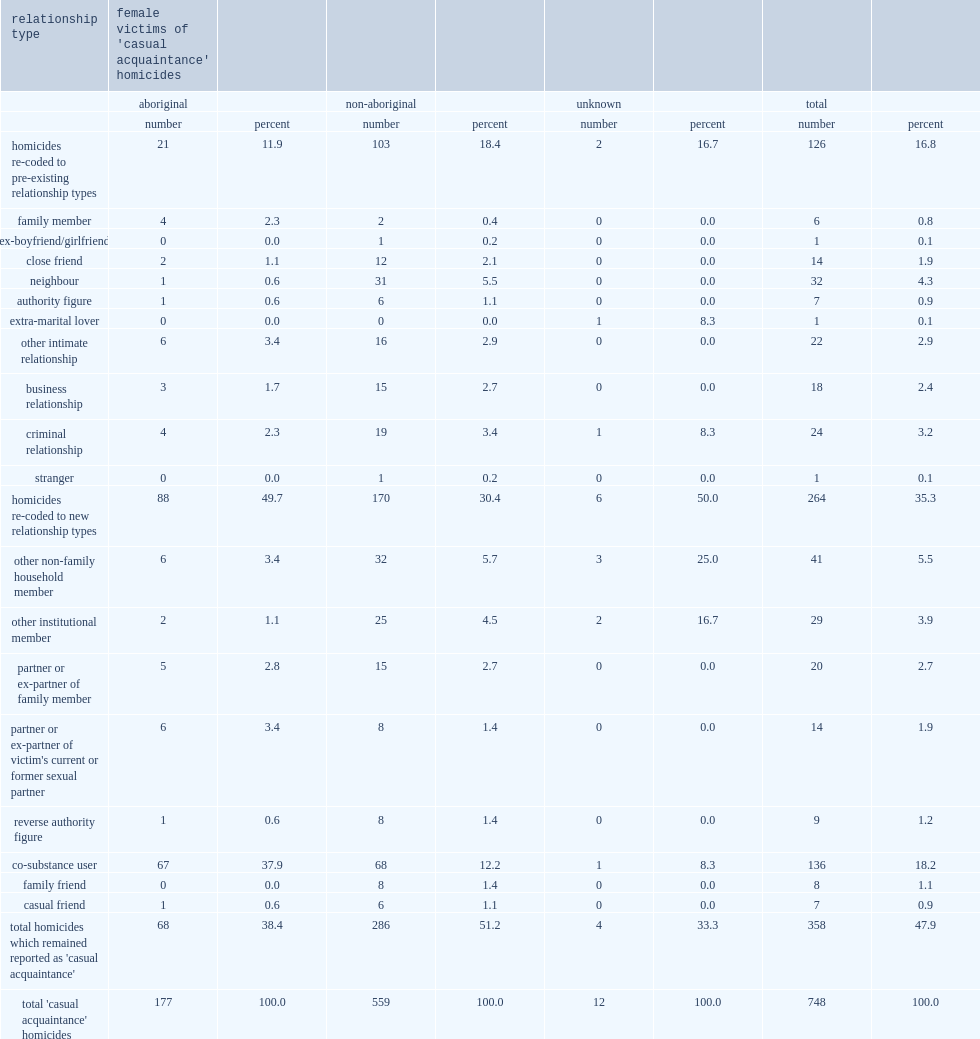Parse the table in full. {'header': ['relationship type', "female victims of 'casual acquaintance' homicides", '', '', '', '', '', '', ''], 'rows': [['', 'aboriginal', '', 'non-aboriginal', '', 'unknown', '', 'total', ''], ['', 'number', 'percent', 'number', 'percent', 'number', 'percent', 'number', 'percent'], ['homicides re-coded to pre-existing relationship types', '21', '11.9', '103', '18.4', '2', '16.7', '126', '16.8'], ['family member', '4', '2.3', '2', '0.4', '0', '0.0', '6', '0.8'], ['ex-boyfriend/girlfriend', '0', '0.0', '1', '0.2', '0', '0.0', '1', '0.1'], ['close friend', '2', '1.1', '12', '2.1', '0', '0.0', '14', '1.9'], ['neighbour', '1', '0.6', '31', '5.5', '0', '0.0', '32', '4.3'], ['authority figure', '1', '0.6', '6', '1.1', '0', '0.0', '7', '0.9'], ['extra-marital lover', '0', '0.0', '0', '0.0', '1', '8.3', '1', '0.1'], ['other intimate relationship', '6', '3.4', '16', '2.9', '0', '0.0', '22', '2.9'], ['business relationship', '3', '1.7', '15', '2.7', '0', '0.0', '18', '2.4'], ['criminal relationship', '4', '2.3', '19', '3.4', '1', '8.3', '24', '3.2'], ['stranger', '0', '0.0', '1', '0.2', '0', '0.0', '1', '0.1'], ['homicides re-coded to new relationship types', '88', '49.7', '170', '30.4', '6', '50.0', '264', '35.3'], ['other non-family household member', '6', '3.4', '32', '5.7', '3', '25.0', '41', '5.5'], ['other institutional member', '2', '1.1', '25', '4.5', '2', '16.7', '29', '3.9'], ['partner or ex-partner of family member', '5', '2.8', '15', '2.7', '0', '0.0', '20', '2.7'], ["partner or ex-partner of victim's current or former sexual partner", '6', '3.4', '8', '1.4', '0', '0.0', '14', '1.9'], ['reverse authority figure', '1', '0.6', '8', '1.4', '0', '0.0', '9', '1.2'], ['co-substance user', '67', '37.9', '68', '12.2', '1', '8.3', '136', '18.2'], ['family friend', '0', '0.0', '8', '1.4', '0', '0.0', '8', '1.1'], ['casual friend', '1', '0.6', '6', '1.1', '0', '0.0', '7', '0.9'], ["total homicides which remained reported as 'casual acquaintance'", '68', '38.4', '286', '51.2', '4', '33.3', '358', '47.9'], ["total 'casual acquaintance' homicides", '177', '100.0', '559', '100.0', '12', '100.0', '748', '100.0']]} What was the total number of female victims of homicide reported as being killed by a 'casual acquaintance'? 748.0. What was the percentage of aboriginal female victims killed by a casual acquaintance of the 6,230 female victims? 0.236631. What was the percentage of victims killed by what can be described as a 'co-substance user' of the 748 victims? 18.2. Among co-substance use,who were more common,aboriginal females or non-aboriginal females? Aboriginal. 